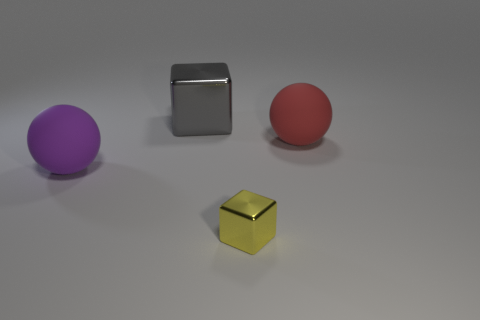There is a ball behind the purple matte thing; is it the same size as the purple object?
Offer a terse response. Yes. What number of things are either small cubes or tiny purple matte spheres?
Keep it short and to the point. 1. What material is the tiny block that is to the right of the big object that is behind the matte sphere that is on the right side of the tiny yellow block made of?
Keep it short and to the point. Metal. What material is the cube that is behind the red matte object?
Keep it short and to the point. Metal. Are there any spheres that have the same size as the red rubber thing?
Offer a very short reply. Yes. How many purple things are rubber balls or small cubes?
Your answer should be very brief. 1. How many shiny things are the same color as the tiny cube?
Ensure brevity in your answer.  0. Does the large gray thing have the same material as the yellow object?
Ensure brevity in your answer.  Yes. How many blocks are in front of the ball on the left side of the yellow metallic thing?
Your answer should be very brief. 1. Does the gray metallic block have the same size as the purple object?
Give a very brief answer. Yes. 